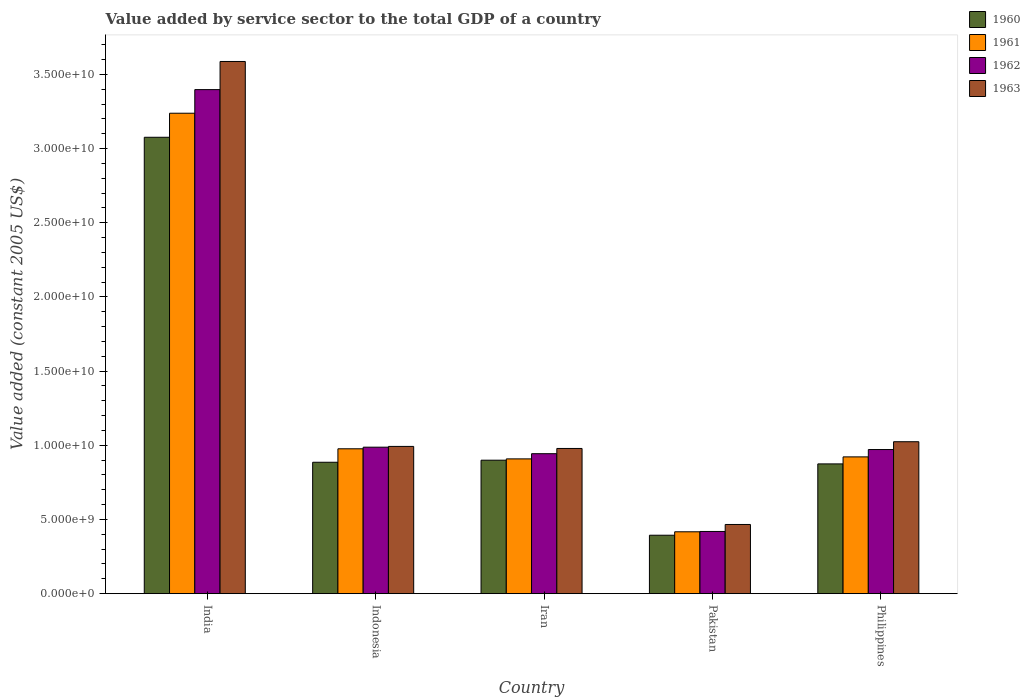How many bars are there on the 2nd tick from the right?
Your answer should be very brief. 4. What is the label of the 5th group of bars from the left?
Your answer should be compact. Philippines. In how many cases, is the number of bars for a given country not equal to the number of legend labels?
Ensure brevity in your answer.  0. What is the value added by service sector in 1960 in Iran?
Make the answer very short. 9.00e+09. Across all countries, what is the maximum value added by service sector in 1960?
Keep it short and to the point. 3.08e+1. Across all countries, what is the minimum value added by service sector in 1963?
Make the answer very short. 4.66e+09. In which country was the value added by service sector in 1960 minimum?
Keep it short and to the point. Pakistan. What is the total value added by service sector in 1963 in the graph?
Offer a terse response. 7.05e+1. What is the difference between the value added by service sector in 1962 in India and that in Philippines?
Provide a succinct answer. 2.43e+1. What is the difference between the value added by service sector in 1962 in Indonesia and the value added by service sector in 1961 in Philippines?
Keep it short and to the point. 6.54e+08. What is the average value added by service sector in 1963 per country?
Your answer should be very brief. 1.41e+1. What is the difference between the value added by service sector of/in 1963 and value added by service sector of/in 1962 in Pakistan?
Your answer should be compact. 4.71e+08. What is the ratio of the value added by service sector in 1961 in Pakistan to that in Philippines?
Your response must be concise. 0.45. What is the difference between the highest and the second highest value added by service sector in 1960?
Give a very brief answer. 2.19e+1. What is the difference between the highest and the lowest value added by service sector in 1963?
Your answer should be very brief. 3.12e+1. Is the sum of the value added by service sector in 1963 in India and Indonesia greater than the maximum value added by service sector in 1962 across all countries?
Your answer should be very brief. Yes. What does the 2nd bar from the right in India represents?
Keep it short and to the point. 1962. How many bars are there?
Your answer should be compact. 20. Are all the bars in the graph horizontal?
Ensure brevity in your answer.  No. What is the difference between two consecutive major ticks on the Y-axis?
Your answer should be very brief. 5.00e+09. Does the graph contain any zero values?
Provide a short and direct response. No. How many legend labels are there?
Keep it short and to the point. 4. How are the legend labels stacked?
Keep it short and to the point. Vertical. What is the title of the graph?
Make the answer very short. Value added by service sector to the total GDP of a country. What is the label or title of the X-axis?
Offer a terse response. Country. What is the label or title of the Y-axis?
Give a very brief answer. Value added (constant 2005 US$). What is the Value added (constant 2005 US$) of 1960 in India?
Provide a succinct answer. 3.08e+1. What is the Value added (constant 2005 US$) in 1961 in India?
Ensure brevity in your answer.  3.24e+1. What is the Value added (constant 2005 US$) in 1962 in India?
Make the answer very short. 3.40e+1. What is the Value added (constant 2005 US$) in 1963 in India?
Your response must be concise. 3.59e+1. What is the Value added (constant 2005 US$) in 1960 in Indonesia?
Your response must be concise. 8.86e+09. What is the Value added (constant 2005 US$) in 1961 in Indonesia?
Your response must be concise. 9.77e+09. What is the Value added (constant 2005 US$) of 1962 in Indonesia?
Provide a short and direct response. 9.88e+09. What is the Value added (constant 2005 US$) in 1963 in Indonesia?
Keep it short and to the point. 9.93e+09. What is the Value added (constant 2005 US$) in 1960 in Iran?
Your response must be concise. 9.00e+09. What is the Value added (constant 2005 US$) of 1961 in Iran?
Offer a terse response. 9.09e+09. What is the Value added (constant 2005 US$) in 1962 in Iran?
Offer a very short reply. 9.44e+09. What is the Value added (constant 2005 US$) in 1963 in Iran?
Your answer should be very brief. 9.79e+09. What is the Value added (constant 2005 US$) in 1960 in Pakistan?
Make the answer very short. 3.94e+09. What is the Value added (constant 2005 US$) of 1961 in Pakistan?
Give a very brief answer. 4.17e+09. What is the Value added (constant 2005 US$) in 1962 in Pakistan?
Offer a very short reply. 4.19e+09. What is the Value added (constant 2005 US$) of 1963 in Pakistan?
Make the answer very short. 4.66e+09. What is the Value added (constant 2005 US$) in 1960 in Philippines?
Your answer should be compact. 8.75e+09. What is the Value added (constant 2005 US$) in 1961 in Philippines?
Provide a succinct answer. 9.22e+09. What is the Value added (constant 2005 US$) of 1962 in Philippines?
Offer a terse response. 9.72e+09. What is the Value added (constant 2005 US$) in 1963 in Philippines?
Offer a terse response. 1.02e+1. Across all countries, what is the maximum Value added (constant 2005 US$) of 1960?
Offer a very short reply. 3.08e+1. Across all countries, what is the maximum Value added (constant 2005 US$) in 1961?
Offer a very short reply. 3.24e+1. Across all countries, what is the maximum Value added (constant 2005 US$) in 1962?
Your answer should be very brief. 3.40e+1. Across all countries, what is the maximum Value added (constant 2005 US$) in 1963?
Provide a short and direct response. 3.59e+1. Across all countries, what is the minimum Value added (constant 2005 US$) of 1960?
Your answer should be very brief. 3.94e+09. Across all countries, what is the minimum Value added (constant 2005 US$) in 1961?
Keep it short and to the point. 4.17e+09. Across all countries, what is the minimum Value added (constant 2005 US$) of 1962?
Your answer should be compact. 4.19e+09. Across all countries, what is the minimum Value added (constant 2005 US$) of 1963?
Your answer should be very brief. 4.66e+09. What is the total Value added (constant 2005 US$) in 1960 in the graph?
Your answer should be compact. 6.13e+1. What is the total Value added (constant 2005 US$) of 1961 in the graph?
Ensure brevity in your answer.  6.46e+1. What is the total Value added (constant 2005 US$) of 1962 in the graph?
Give a very brief answer. 6.72e+1. What is the total Value added (constant 2005 US$) of 1963 in the graph?
Provide a short and direct response. 7.05e+1. What is the difference between the Value added (constant 2005 US$) of 1960 in India and that in Indonesia?
Ensure brevity in your answer.  2.19e+1. What is the difference between the Value added (constant 2005 US$) in 1961 in India and that in Indonesia?
Offer a very short reply. 2.26e+1. What is the difference between the Value added (constant 2005 US$) of 1962 in India and that in Indonesia?
Offer a terse response. 2.41e+1. What is the difference between the Value added (constant 2005 US$) of 1963 in India and that in Indonesia?
Offer a terse response. 2.60e+1. What is the difference between the Value added (constant 2005 US$) of 1960 in India and that in Iran?
Make the answer very short. 2.18e+1. What is the difference between the Value added (constant 2005 US$) in 1961 in India and that in Iran?
Your answer should be very brief. 2.33e+1. What is the difference between the Value added (constant 2005 US$) of 1962 in India and that in Iran?
Your response must be concise. 2.45e+1. What is the difference between the Value added (constant 2005 US$) in 1963 in India and that in Iran?
Keep it short and to the point. 2.61e+1. What is the difference between the Value added (constant 2005 US$) of 1960 in India and that in Pakistan?
Give a very brief answer. 2.68e+1. What is the difference between the Value added (constant 2005 US$) in 1961 in India and that in Pakistan?
Your response must be concise. 2.82e+1. What is the difference between the Value added (constant 2005 US$) of 1962 in India and that in Pakistan?
Offer a very short reply. 2.98e+1. What is the difference between the Value added (constant 2005 US$) of 1963 in India and that in Pakistan?
Provide a succinct answer. 3.12e+1. What is the difference between the Value added (constant 2005 US$) in 1960 in India and that in Philippines?
Offer a very short reply. 2.20e+1. What is the difference between the Value added (constant 2005 US$) of 1961 in India and that in Philippines?
Make the answer very short. 2.32e+1. What is the difference between the Value added (constant 2005 US$) of 1962 in India and that in Philippines?
Ensure brevity in your answer.  2.43e+1. What is the difference between the Value added (constant 2005 US$) in 1963 in India and that in Philippines?
Make the answer very short. 2.56e+1. What is the difference between the Value added (constant 2005 US$) of 1960 in Indonesia and that in Iran?
Provide a succinct answer. -1.39e+08. What is the difference between the Value added (constant 2005 US$) in 1961 in Indonesia and that in Iran?
Ensure brevity in your answer.  6.80e+08. What is the difference between the Value added (constant 2005 US$) in 1962 in Indonesia and that in Iran?
Provide a succinct answer. 4.39e+08. What is the difference between the Value added (constant 2005 US$) of 1963 in Indonesia and that in Iran?
Provide a short and direct response. 1.38e+08. What is the difference between the Value added (constant 2005 US$) of 1960 in Indonesia and that in Pakistan?
Offer a terse response. 4.92e+09. What is the difference between the Value added (constant 2005 US$) of 1961 in Indonesia and that in Pakistan?
Your response must be concise. 5.60e+09. What is the difference between the Value added (constant 2005 US$) of 1962 in Indonesia and that in Pakistan?
Provide a short and direct response. 5.68e+09. What is the difference between the Value added (constant 2005 US$) of 1963 in Indonesia and that in Pakistan?
Offer a very short reply. 5.26e+09. What is the difference between the Value added (constant 2005 US$) in 1960 in Indonesia and that in Philippines?
Provide a short and direct response. 1.10e+08. What is the difference between the Value added (constant 2005 US$) of 1961 in Indonesia and that in Philippines?
Your answer should be very brief. 5.45e+08. What is the difference between the Value added (constant 2005 US$) in 1962 in Indonesia and that in Philippines?
Your answer should be compact. 1.59e+08. What is the difference between the Value added (constant 2005 US$) in 1963 in Indonesia and that in Philippines?
Your response must be concise. -3.16e+08. What is the difference between the Value added (constant 2005 US$) of 1960 in Iran and that in Pakistan?
Ensure brevity in your answer.  5.06e+09. What is the difference between the Value added (constant 2005 US$) of 1961 in Iran and that in Pakistan?
Your answer should be very brief. 4.92e+09. What is the difference between the Value added (constant 2005 US$) of 1962 in Iran and that in Pakistan?
Provide a succinct answer. 5.24e+09. What is the difference between the Value added (constant 2005 US$) of 1963 in Iran and that in Pakistan?
Ensure brevity in your answer.  5.12e+09. What is the difference between the Value added (constant 2005 US$) of 1960 in Iran and that in Philippines?
Your answer should be very brief. 2.49e+08. What is the difference between the Value added (constant 2005 US$) in 1961 in Iran and that in Philippines?
Give a very brief answer. -1.35e+08. What is the difference between the Value added (constant 2005 US$) of 1962 in Iran and that in Philippines?
Ensure brevity in your answer.  -2.80e+08. What is the difference between the Value added (constant 2005 US$) in 1963 in Iran and that in Philippines?
Your answer should be very brief. -4.54e+08. What is the difference between the Value added (constant 2005 US$) of 1960 in Pakistan and that in Philippines?
Keep it short and to the point. -4.81e+09. What is the difference between the Value added (constant 2005 US$) in 1961 in Pakistan and that in Philippines?
Your response must be concise. -5.05e+09. What is the difference between the Value added (constant 2005 US$) of 1962 in Pakistan and that in Philippines?
Your answer should be compact. -5.52e+09. What is the difference between the Value added (constant 2005 US$) of 1963 in Pakistan and that in Philippines?
Keep it short and to the point. -5.58e+09. What is the difference between the Value added (constant 2005 US$) of 1960 in India and the Value added (constant 2005 US$) of 1961 in Indonesia?
Keep it short and to the point. 2.10e+1. What is the difference between the Value added (constant 2005 US$) of 1960 in India and the Value added (constant 2005 US$) of 1962 in Indonesia?
Offer a very short reply. 2.09e+1. What is the difference between the Value added (constant 2005 US$) of 1960 in India and the Value added (constant 2005 US$) of 1963 in Indonesia?
Offer a terse response. 2.08e+1. What is the difference between the Value added (constant 2005 US$) in 1961 in India and the Value added (constant 2005 US$) in 1962 in Indonesia?
Ensure brevity in your answer.  2.25e+1. What is the difference between the Value added (constant 2005 US$) of 1961 in India and the Value added (constant 2005 US$) of 1963 in Indonesia?
Your response must be concise. 2.25e+1. What is the difference between the Value added (constant 2005 US$) in 1962 in India and the Value added (constant 2005 US$) in 1963 in Indonesia?
Provide a short and direct response. 2.41e+1. What is the difference between the Value added (constant 2005 US$) of 1960 in India and the Value added (constant 2005 US$) of 1961 in Iran?
Your answer should be very brief. 2.17e+1. What is the difference between the Value added (constant 2005 US$) in 1960 in India and the Value added (constant 2005 US$) in 1962 in Iran?
Your answer should be very brief. 2.13e+1. What is the difference between the Value added (constant 2005 US$) in 1960 in India and the Value added (constant 2005 US$) in 1963 in Iran?
Your response must be concise. 2.10e+1. What is the difference between the Value added (constant 2005 US$) in 1961 in India and the Value added (constant 2005 US$) in 1962 in Iran?
Offer a very short reply. 2.30e+1. What is the difference between the Value added (constant 2005 US$) in 1961 in India and the Value added (constant 2005 US$) in 1963 in Iran?
Provide a succinct answer. 2.26e+1. What is the difference between the Value added (constant 2005 US$) in 1962 in India and the Value added (constant 2005 US$) in 1963 in Iran?
Make the answer very short. 2.42e+1. What is the difference between the Value added (constant 2005 US$) of 1960 in India and the Value added (constant 2005 US$) of 1961 in Pakistan?
Your answer should be compact. 2.66e+1. What is the difference between the Value added (constant 2005 US$) in 1960 in India and the Value added (constant 2005 US$) in 1962 in Pakistan?
Your answer should be very brief. 2.66e+1. What is the difference between the Value added (constant 2005 US$) in 1960 in India and the Value added (constant 2005 US$) in 1963 in Pakistan?
Keep it short and to the point. 2.61e+1. What is the difference between the Value added (constant 2005 US$) in 1961 in India and the Value added (constant 2005 US$) in 1962 in Pakistan?
Ensure brevity in your answer.  2.82e+1. What is the difference between the Value added (constant 2005 US$) in 1961 in India and the Value added (constant 2005 US$) in 1963 in Pakistan?
Ensure brevity in your answer.  2.77e+1. What is the difference between the Value added (constant 2005 US$) in 1962 in India and the Value added (constant 2005 US$) in 1963 in Pakistan?
Offer a terse response. 2.93e+1. What is the difference between the Value added (constant 2005 US$) in 1960 in India and the Value added (constant 2005 US$) in 1961 in Philippines?
Offer a terse response. 2.15e+1. What is the difference between the Value added (constant 2005 US$) in 1960 in India and the Value added (constant 2005 US$) in 1962 in Philippines?
Your answer should be compact. 2.11e+1. What is the difference between the Value added (constant 2005 US$) in 1960 in India and the Value added (constant 2005 US$) in 1963 in Philippines?
Offer a terse response. 2.05e+1. What is the difference between the Value added (constant 2005 US$) of 1961 in India and the Value added (constant 2005 US$) of 1962 in Philippines?
Ensure brevity in your answer.  2.27e+1. What is the difference between the Value added (constant 2005 US$) of 1961 in India and the Value added (constant 2005 US$) of 1963 in Philippines?
Your response must be concise. 2.21e+1. What is the difference between the Value added (constant 2005 US$) of 1962 in India and the Value added (constant 2005 US$) of 1963 in Philippines?
Keep it short and to the point. 2.37e+1. What is the difference between the Value added (constant 2005 US$) in 1960 in Indonesia and the Value added (constant 2005 US$) in 1961 in Iran?
Provide a short and direct response. -2.28e+08. What is the difference between the Value added (constant 2005 US$) of 1960 in Indonesia and the Value added (constant 2005 US$) of 1962 in Iran?
Make the answer very short. -5.77e+08. What is the difference between the Value added (constant 2005 US$) of 1960 in Indonesia and the Value added (constant 2005 US$) of 1963 in Iran?
Ensure brevity in your answer.  -9.30e+08. What is the difference between the Value added (constant 2005 US$) of 1961 in Indonesia and the Value added (constant 2005 US$) of 1962 in Iran?
Your response must be concise. 3.30e+08. What is the difference between the Value added (constant 2005 US$) of 1961 in Indonesia and the Value added (constant 2005 US$) of 1963 in Iran?
Offer a terse response. -2.20e+07. What is the difference between the Value added (constant 2005 US$) of 1962 in Indonesia and the Value added (constant 2005 US$) of 1963 in Iran?
Offer a very short reply. 8.67e+07. What is the difference between the Value added (constant 2005 US$) in 1960 in Indonesia and the Value added (constant 2005 US$) in 1961 in Pakistan?
Keep it short and to the point. 4.69e+09. What is the difference between the Value added (constant 2005 US$) of 1960 in Indonesia and the Value added (constant 2005 US$) of 1962 in Pakistan?
Offer a terse response. 4.66e+09. What is the difference between the Value added (constant 2005 US$) of 1960 in Indonesia and the Value added (constant 2005 US$) of 1963 in Pakistan?
Provide a short and direct response. 4.19e+09. What is the difference between the Value added (constant 2005 US$) in 1961 in Indonesia and the Value added (constant 2005 US$) in 1962 in Pakistan?
Ensure brevity in your answer.  5.57e+09. What is the difference between the Value added (constant 2005 US$) in 1961 in Indonesia and the Value added (constant 2005 US$) in 1963 in Pakistan?
Give a very brief answer. 5.10e+09. What is the difference between the Value added (constant 2005 US$) in 1962 in Indonesia and the Value added (constant 2005 US$) in 1963 in Pakistan?
Provide a short and direct response. 5.21e+09. What is the difference between the Value added (constant 2005 US$) in 1960 in Indonesia and the Value added (constant 2005 US$) in 1961 in Philippines?
Offer a terse response. -3.63e+08. What is the difference between the Value added (constant 2005 US$) of 1960 in Indonesia and the Value added (constant 2005 US$) of 1962 in Philippines?
Your answer should be compact. -8.58e+08. What is the difference between the Value added (constant 2005 US$) in 1960 in Indonesia and the Value added (constant 2005 US$) in 1963 in Philippines?
Your answer should be very brief. -1.38e+09. What is the difference between the Value added (constant 2005 US$) of 1961 in Indonesia and the Value added (constant 2005 US$) of 1962 in Philippines?
Your response must be concise. 5.00e+07. What is the difference between the Value added (constant 2005 US$) in 1961 in Indonesia and the Value added (constant 2005 US$) in 1963 in Philippines?
Provide a succinct answer. -4.76e+08. What is the difference between the Value added (constant 2005 US$) in 1962 in Indonesia and the Value added (constant 2005 US$) in 1963 in Philippines?
Keep it short and to the point. -3.68e+08. What is the difference between the Value added (constant 2005 US$) in 1960 in Iran and the Value added (constant 2005 US$) in 1961 in Pakistan?
Your answer should be compact. 4.83e+09. What is the difference between the Value added (constant 2005 US$) in 1960 in Iran and the Value added (constant 2005 US$) in 1962 in Pakistan?
Your answer should be compact. 4.80e+09. What is the difference between the Value added (constant 2005 US$) of 1960 in Iran and the Value added (constant 2005 US$) of 1963 in Pakistan?
Keep it short and to the point. 4.33e+09. What is the difference between the Value added (constant 2005 US$) of 1961 in Iran and the Value added (constant 2005 US$) of 1962 in Pakistan?
Give a very brief answer. 4.89e+09. What is the difference between the Value added (constant 2005 US$) of 1961 in Iran and the Value added (constant 2005 US$) of 1963 in Pakistan?
Make the answer very short. 4.42e+09. What is the difference between the Value added (constant 2005 US$) of 1962 in Iran and the Value added (constant 2005 US$) of 1963 in Pakistan?
Offer a terse response. 4.77e+09. What is the difference between the Value added (constant 2005 US$) in 1960 in Iran and the Value added (constant 2005 US$) in 1961 in Philippines?
Keep it short and to the point. -2.24e+08. What is the difference between the Value added (constant 2005 US$) in 1960 in Iran and the Value added (constant 2005 US$) in 1962 in Philippines?
Your response must be concise. -7.19e+08. What is the difference between the Value added (constant 2005 US$) in 1960 in Iran and the Value added (constant 2005 US$) in 1963 in Philippines?
Provide a short and direct response. -1.25e+09. What is the difference between the Value added (constant 2005 US$) of 1961 in Iran and the Value added (constant 2005 US$) of 1962 in Philippines?
Your answer should be compact. -6.30e+08. What is the difference between the Value added (constant 2005 US$) of 1961 in Iran and the Value added (constant 2005 US$) of 1963 in Philippines?
Give a very brief answer. -1.16e+09. What is the difference between the Value added (constant 2005 US$) of 1962 in Iran and the Value added (constant 2005 US$) of 1963 in Philippines?
Your answer should be very brief. -8.07e+08. What is the difference between the Value added (constant 2005 US$) in 1960 in Pakistan and the Value added (constant 2005 US$) in 1961 in Philippines?
Make the answer very short. -5.28e+09. What is the difference between the Value added (constant 2005 US$) in 1960 in Pakistan and the Value added (constant 2005 US$) in 1962 in Philippines?
Give a very brief answer. -5.78e+09. What is the difference between the Value added (constant 2005 US$) in 1960 in Pakistan and the Value added (constant 2005 US$) in 1963 in Philippines?
Make the answer very short. -6.30e+09. What is the difference between the Value added (constant 2005 US$) of 1961 in Pakistan and the Value added (constant 2005 US$) of 1962 in Philippines?
Your response must be concise. -5.55e+09. What is the difference between the Value added (constant 2005 US$) of 1961 in Pakistan and the Value added (constant 2005 US$) of 1963 in Philippines?
Ensure brevity in your answer.  -6.07e+09. What is the difference between the Value added (constant 2005 US$) of 1962 in Pakistan and the Value added (constant 2005 US$) of 1963 in Philippines?
Your answer should be very brief. -6.05e+09. What is the average Value added (constant 2005 US$) in 1960 per country?
Ensure brevity in your answer.  1.23e+1. What is the average Value added (constant 2005 US$) in 1961 per country?
Your answer should be compact. 1.29e+1. What is the average Value added (constant 2005 US$) in 1962 per country?
Give a very brief answer. 1.34e+1. What is the average Value added (constant 2005 US$) in 1963 per country?
Provide a short and direct response. 1.41e+1. What is the difference between the Value added (constant 2005 US$) of 1960 and Value added (constant 2005 US$) of 1961 in India?
Give a very brief answer. -1.62e+09. What is the difference between the Value added (constant 2005 US$) of 1960 and Value added (constant 2005 US$) of 1962 in India?
Your answer should be compact. -3.21e+09. What is the difference between the Value added (constant 2005 US$) of 1960 and Value added (constant 2005 US$) of 1963 in India?
Your answer should be compact. -5.11e+09. What is the difference between the Value added (constant 2005 US$) in 1961 and Value added (constant 2005 US$) in 1962 in India?
Give a very brief answer. -1.59e+09. What is the difference between the Value added (constant 2005 US$) of 1961 and Value added (constant 2005 US$) of 1963 in India?
Make the answer very short. -3.49e+09. What is the difference between the Value added (constant 2005 US$) of 1962 and Value added (constant 2005 US$) of 1963 in India?
Your answer should be very brief. -1.90e+09. What is the difference between the Value added (constant 2005 US$) of 1960 and Value added (constant 2005 US$) of 1961 in Indonesia?
Ensure brevity in your answer.  -9.08e+08. What is the difference between the Value added (constant 2005 US$) in 1960 and Value added (constant 2005 US$) in 1962 in Indonesia?
Provide a succinct answer. -1.02e+09. What is the difference between the Value added (constant 2005 US$) of 1960 and Value added (constant 2005 US$) of 1963 in Indonesia?
Provide a short and direct response. -1.07e+09. What is the difference between the Value added (constant 2005 US$) of 1961 and Value added (constant 2005 US$) of 1962 in Indonesia?
Make the answer very short. -1.09e+08. What is the difference between the Value added (constant 2005 US$) of 1961 and Value added (constant 2005 US$) of 1963 in Indonesia?
Offer a very short reply. -1.60e+08. What is the difference between the Value added (constant 2005 US$) in 1962 and Value added (constant 2005 US$) in 1963 in Indonesia?
Your answer should be very brief. -5.15e+07. What is the difference between the Value added (constant 2005 US$) of 1960 and Value added (constant 2005 US$) of 1961 in Iran?
Provide a short and direct response. -8.88e+07. What is the difference between the Value added (constant 2005 US$) of 1960 and Value added (constant 2005 US$) of 1962 in Iran?
Offer a very short reply. -4.39e+08. What is the difference between the Value added (constant 2005 US$) in 1960 and Value added (constant 2005 US$) in 1963 in Iran?
Offer a very short reply. -7.91e+08. What is the difference between the Value added (constant 2005 US$) of 1961 and Value added (constant 2005 US$) of 1962 in Iran?
Your answer should be very brief. -3.50e+08. What is the difference between the Value added (constant 2005 US$) of 1961 and Value added (constant 2005 US$) of 1963 in Iran?
Give a very brief answer. -7.02e+08. What is the difference between the Value added (constant 2005 US$) in 1962 and Value added (constant 2005 US$) in 1963 in Iran?
Your answer should be compact. -3.52e+08. What is the difference between the Value added (constant 2005 US$) in 1960 and Value added (constant 2005 US$) in 1961 in Pakistan?
Your answer should be very brief. -2.32e+08. What is the difference between the Value added (constant 2005 US$) in 1960 and Value added (constant 2005 US$) in 1962 in Pakistan?
Provide a succinct answer. -2.54e+08. What is the difference between the Value added (constant 2005 US$) of 1960 and Value added (constant 2005 US$) of 1963 in Pakistan?
Provide a short and direct response. -7.25e+08. What is the difference between the Value added (constant 2005 US$) of 1961 and Value added (constant 2005 US$) of 1962 in Pakistan?
Ensure brevity in your answer.  -2.26e+07. What is the difference between the Value added (constant 2005 US$) of 1961 and Value added (constant 2005 US$) of 1963 in Pakistan?
Ensure brevity in your answer.  -4.93e+08. What is the difference between the Value added (constant 2005 US$) of 1962 and Value added (constant 2005 US$) of 1963 in Pakistan?
Your answer should be very brief. -4.71e+08. What is the difference between the Value added (constant 2005 US$) of 1960 and Value added (constant 2005 US$) of 1961 in Philippines?
Your answer should be very brief. -4.73e+08. What is the difference between the Value added (constant 2005 US$) of 1960 and Value added (constant 2005 US$) of 1962 in Philippines?
Give a very brief answer. -9.68e+08. What is the difference between the Value added (constant 2005 US$) of 1960 and Value added (constant 2005 US$) of 1963 in Philippines?
Keep it short and to the point. -1.49e+09. What is the difference between the Value added (constant 2005 US$) in 1961 and Value added (constant 2005 US$) in 1962 in Philippines?
Keep it short and to the point. -4.95e+08. What is the difference between the Value added (constant 2005 US$) in 1961 and Value added (constant 2005 US$) in 1963 in Philippines?
Provide a short and direct response. -1.02e+09. What is the difference between the Value added (constant 2005 US$) in 1962 and Value added (constant 2005 US$) in 1963 in Philippines?
Your answer should be very brief. -5.27e+08. What is the ratio of the Value added (constant 2005 US$) of 1960 in India to that in Indonesia?
Offer a very short reply. 3.47. What is the ratio of the Value added (constant 2005 US$) in 1961 in India to that in Indonesia?
Your response must be concise. 3.32. What is the ratio of the Value added (constant 2005 US$) of 1962 in India to that in Indonesia?
Ensure brevity in your answer.  3.44. What is the ratio of the Value added (constant 2005 US$) of 1963 in India to that in Indonesia?
Give a very brief answer. 3.61. What is the ratio of the Value added (constant 2005 US$) in 1960 in India to that in Iran?
Ensure brevity in your answer.  3.42. What is the ratio of the Value added (constant 2005 US$) of 1961 in India to that in Iran?
Your answer should be compact. 3.56. What is the ratio of the Value added (constant 2005 US$) in 1962 in India to that in Iran?
Offer a very short reply. 3.6. What is the ratio of the Value added (constant 2005 US$) of 1963 in India to that in Iran?
Your answer should be compact. 3.67. What is the ratio of the Value added (constant 2005 US$) in 1960 in India to that in Pakistan?
Provide a succinct answer. 7.81. What is the ratio of the Value added (constant 2005 US$) in 1961 in India to that in Pakistan?
Make the answer very short. 7.77. What is the ratio of the Value added (constant 2005 US$) in 1962 in India to that in Pakistan?
Offer a terse response. 8.1. What is the ratio of the Value added (constant 2005 US$) of 1963 in India to that in Pakistan?
Your answer should be very brief. 7.69. What is the ratio of the Value added (constant 2005 US$) in 1960 in India to that in Philippines?
Your answer should be very brief. 3.52. What is the ratio of the Value added (constant 2005 US$) in 1961 in India to that in Philippines?
Offer a terse response. 3.51. What is the ratio of the Value added (constant 2005 US$) of 1962 in India to that in Philippines?
Provide a succinct answer. 3.5. What is the ratio of the Value added (constant 2005 US$) in 1963 in India to that in Philippines?
Your answer should be compact. 3.5. What is the ratio of the Value added (constant 2005 US$) in 1960 in Indonesia to that in Iran?
Make the answer very short. 0.98. What is the ratio of the Value added (constant 2005 US$) in 1961 in Indonesia to that in Iran?
Your answer should be very brief. 1.07. What is the ratio of the Value added (constant 2005 US$) in 1962 in Indonesia to that in Iran?
Your response must be concise. 1.05. What is the ratio of the Value added (constant 2005 US$) in 1963 in Indonesia to that in Iran?
Give a very brief answer. 1.01. What is the ratio of the Value added (constant 2005 US$) of 1960 in Indonesia to that in Pakistan?
Your response must be concise. 2.25. What is the ratio of the Value added (constant 2005 US$) in 1961 in Indonesia to that in Pakistan?
Offer a very short reply. 2.34. What is the ratio of the Value added (constant 2005 US$) of 1962 in Indonesia to that in Pakistan?
Provide a short and direct response. 2.35. What is the ratio of the Value added (constant 2005 US$) in 1963 in Indonesia to that in Pakistan?
Make the answer very short. 2.13. What is the ratio of the Value added (constant 2005 US$) of 1960 in Indonesia to that in Philippines?
Your answer should be compact. 1.01. What is the ratio of the Value added (constant 2005 US$) in 1961 in Indonesia to that in Philippines?
Your answer should be very brief. 1.06. What is the ratio of the Value added (constant 2005 US$) of 1962 in Indonesia to that in Philippines?
Make the answer very short. 1.02. What is the ratio of the Value added (constant 2005 US$) of 1963 in Indonesia to that in Philippines?
Ensure brevity in your answer.  0.97. What is the ratio of the Value added (constant 2005 US$) of 1960 in Iran to that in Pakistan?
Offer a very short reply. 2.28. What is the ratio of the Value added (constant 2005 US$) in 1961 in Iran to that in Pakistan?
Your answer should be compact. 2.18. What is the ratio of the Value added (constant 2005 US$) in 1962 in Iran to that in Pakistan?
Keep it short and to the point. 2.25. What is the ratio of the Value added (constant 2005 US$) of 1963 in Iran to that in Pakistan?
Give a very brief answer. 2.1. What is the ratio of the Value added (constant 2005 US$) in 1960 in Iran to that in Philippines?
Provide a succinct answer. 1.03. What is the ratio of the Value added (constant 2005 US$) in 1961 in Iran to that in Philippines?
Make the answer very short. 0.99. What is the ratio of the Value added (constant 2005 US$) of 1962 in Iran to that in Philippines?
Your answer should be very brief. 0.97. What is the ratio of the Value added (constant 2005 US$) of 1963 in Iran to that in Philippines?
Keep it short and to the point. 0.96. What is the ratio of the Value added (constant 2005 US$) of 1960 in Pakistan to that in Philippines?
Keep it short and to the point. 0.45. What is the ratio of the Value added (constant 2005 US$) of 1961 in Pakistan to that in Philippines?
Your answer should be very brief. 0.45. What is the ratio of the Value added (constant 2005 US$) of 1962 in Pakistan to that in Philippines?
Your response must be concise. 0.43. What is the ratio of the Value added (constant 2005 US$) of 1963 in Pakistan to that in Philippines?
Ensure brevity in your answer.  0.46. What is the difference between the highest and the second highest Value added (constant 2005 US$) in 1960?
Ensure brevity in your answer.  2.18e+1. What is the difference between the highest and the second highest Value added (constant 2005 US$) in 1961?
Offer a very short reply. 2.26e+1. What is the difference between the highest and the second highest Value added (constant 2005 US$) of 1962?
Offer a terse response. 2.41e+1. What is the difference between the highest and the second highest Value added (constant 2005 US$) of 1963?
Offer a very short reply. 2.56e+1. What is the difference between the highest and the lowest Value added (constant 2005 US$) in 1960?
Make the answer very short. 2.68e+1. What is the difference between the highest and the lowest Value added (constant 2005 US$) in 1961?
Your answer should be very brief. 2.82e+1. What is the difference between the highest and the lowest Value added (constant 2005 US$) of 1962?
Provide a short and direct response. 2.98e+1. What is the difference between the highest and the lowest Value added (constant 2005 US$) of 1963?
Keep it short and to the point. 3.12e+1. 